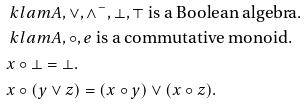Convert formula to latex. <formula><loc_0><loc_0><loc_500><loc_500>& \ k l a m { A , \lor , \land ^ { - } , \bot , \top } \text { is a Boolean algebra} . \\ & \ k l a m { A , \circ , e } \text { is a commutative monoid.} \\ & x \circ \bot = \bot . \\ & x \circ ( y \lor z ) = ( x \circ y ) \lor ( x \circ z ) .</formula> 